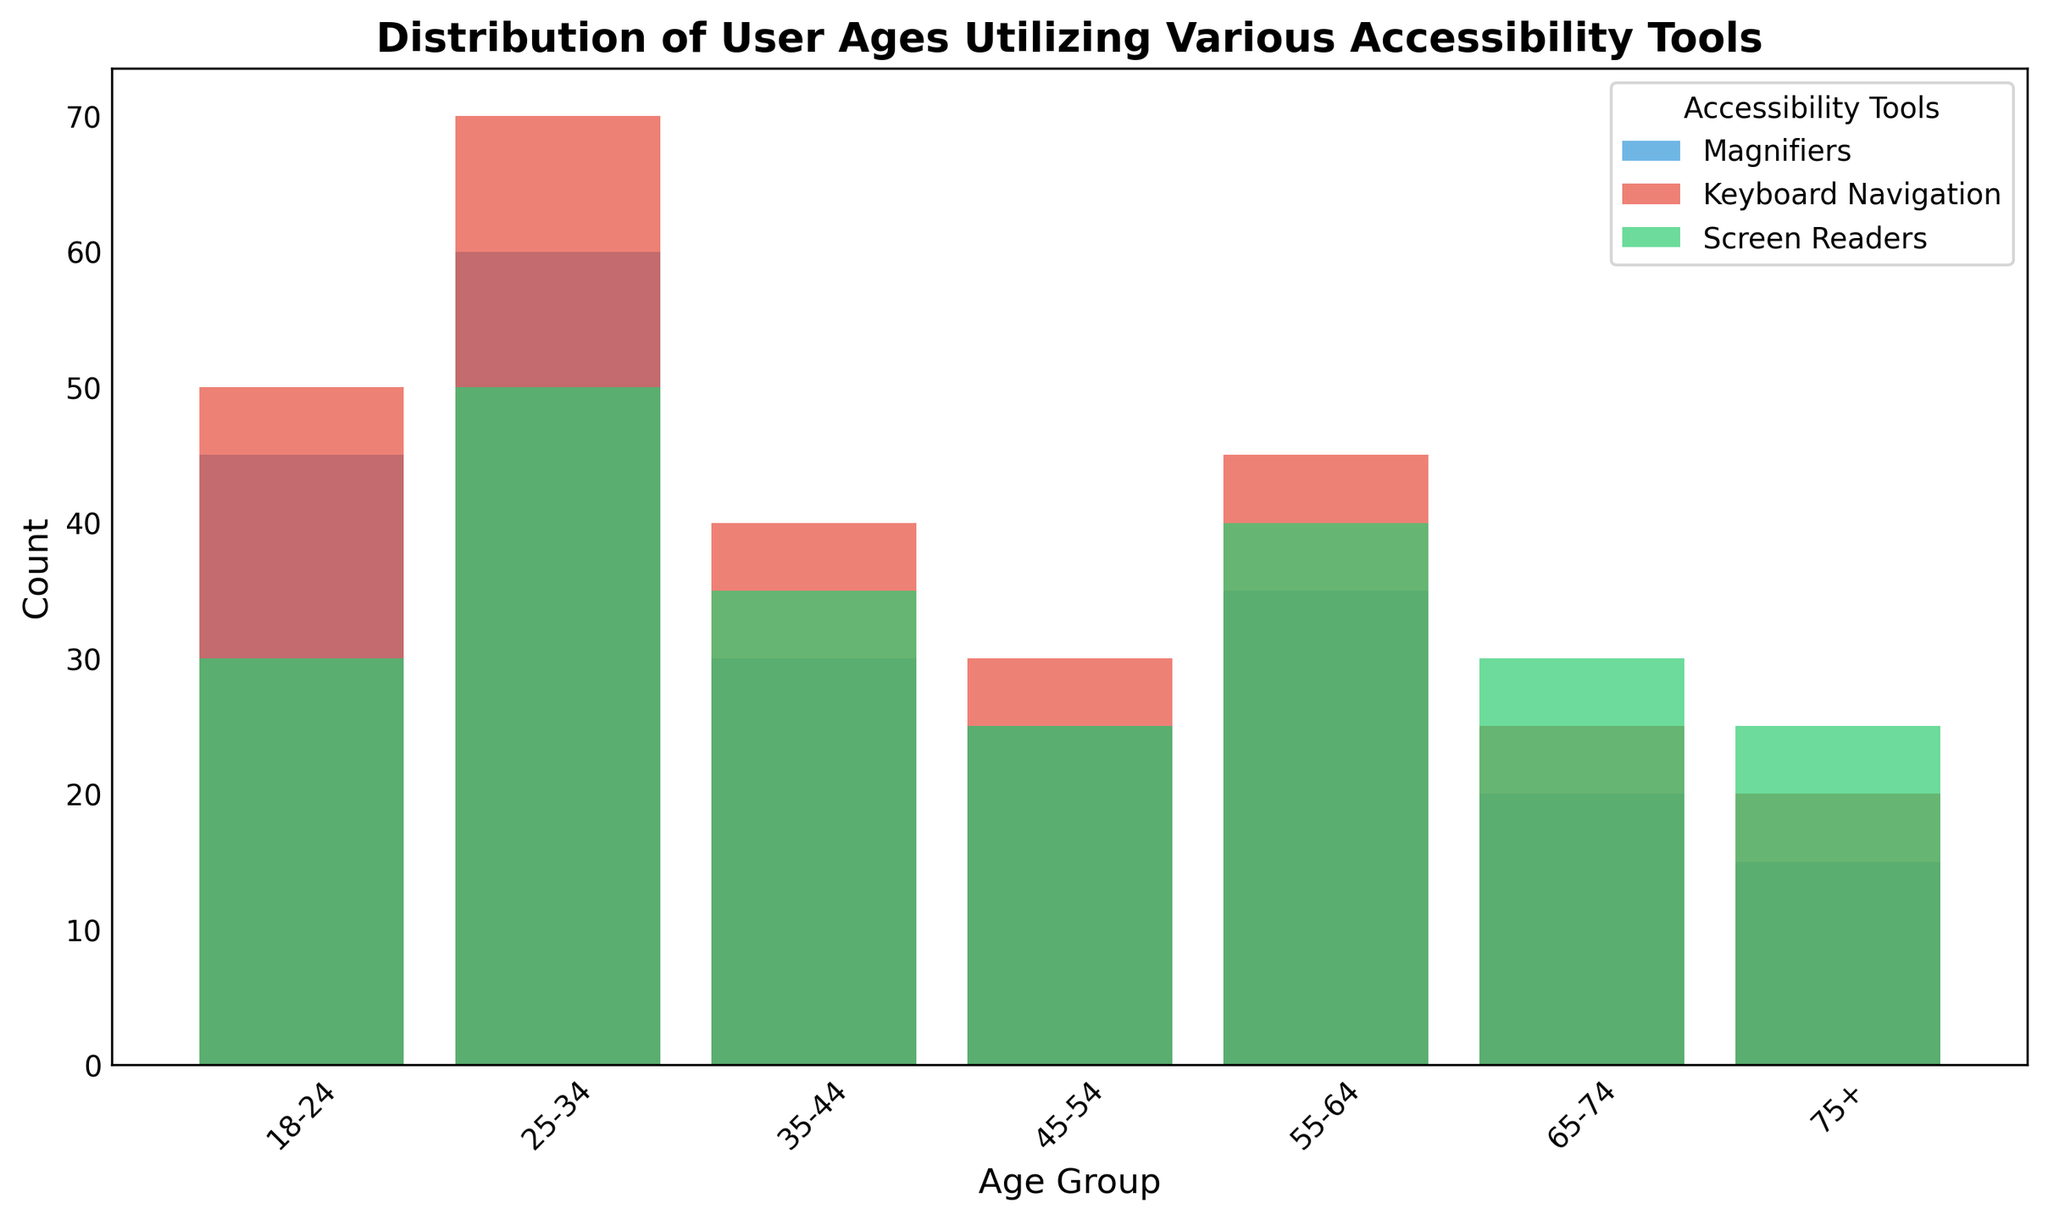Which age group has the highest usage of keyboard navigation? To determine the age group with the highest usage of keyboard navigation, observe the height of the bars corresponding to "Keyboard Navigation." The bar for age group 25-34 is the tallest among all age groups.
Answer: 25-34 Which accessibility tool is most popular among users aged 55-64? Compare the heights of the bars for age group 55-64. The tallest bar is for "Keyboard Navigation."
Answer: Keyboard Navigation What is the difference in the count of users aged 18-24 using magnifiers and screen readers? Look at the bars for age group 18-24. The count for magnifiers is 45, and for screen readers, it is 30. The difference is 45 - 30 = 15.
Answer: 15 Which age group uses screen readers the least? Identify the shortest bar corresponding to "Screen Readers." The bar for age group 45-54 is the shortest one.
Answer: 45-54 How many users in total utilize magnifiers across all age groups? Sum the counts for magnifiers in all age groups: 45 + 60 + 30 + 25 + 35 + 20 + 15 = 230.
Answer: 230 Is there any age group where the usage of keyboard navigation exceeds 60? Check the heights of the bars labeled "Keyboard Navigation." Only the age group 25-34 has a count of 70, which exceeds 60.
Answer: Yes, 25-34 Which tool do users aged 35-44 use the most? For age group 35-44, compare the heights of the bars for each tool. The tallest bar represents "Keyboard Navigation."
Answer: Keyboard Navigation What is the sum of users aged 65-74 using all three accessibility tools? Sum the counts for age group 65-74: Magnifiers (20) + Keyboard Navigation (25) + Screen Readers (30). 20 + 25 + 30 = 75.
Answer: 75 How does the usage of magnifiers change from ages 18-24 to 75+? Observe the bars for magnifiers from ages 18-24 to 75+. The count starts at 45 and decreases gradually to 15.
Answer: Decreases Which accessibility tool has the most uniform usage across all age groups? Examine the variance in bar heights for each tool. "Keyboard Navigation" shows the most consistent heights across age groups compared to the other tools.
Answer: Keyboard Navigation 